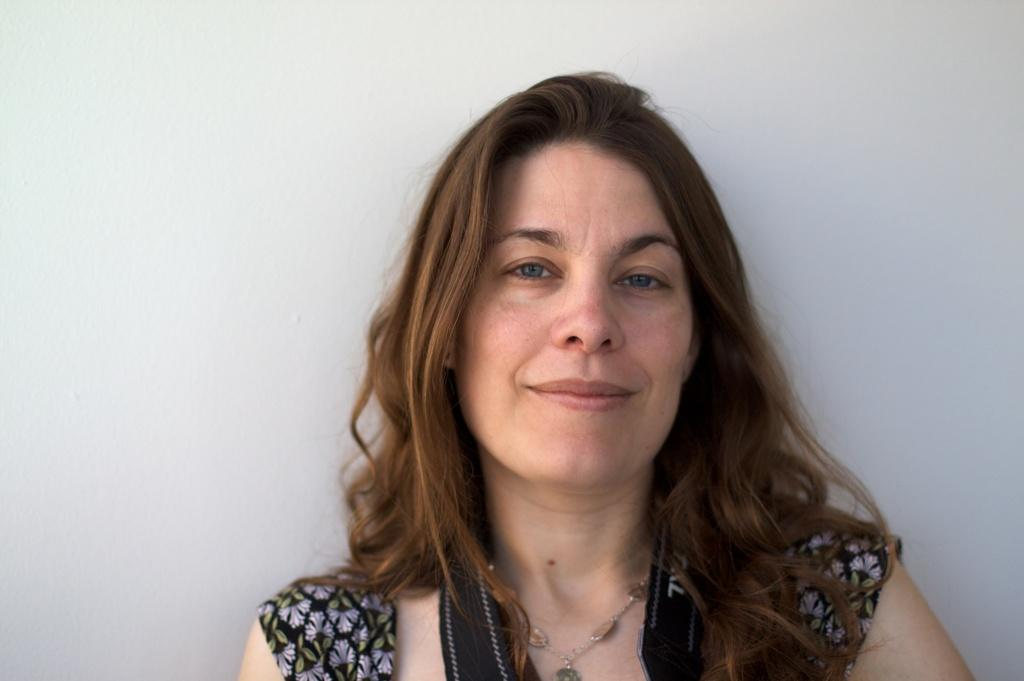What is the color of the wall in the image? There is a white color wall in the image. What else can be seen in the image besides the wall? There is a woman in the image. What is the woman wearing in the image? The woman is wearing a black color dress. Where can the cars be seen parked in the image? There are no cars present in the image. What type of activity is happening in the park in the image? There is no park present in the image. 